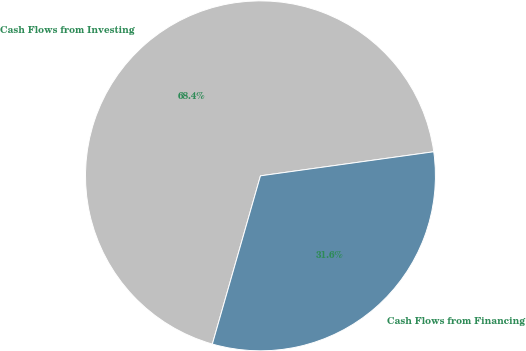Convert chart. <chart><loc_0><loc_0><loc_500><loc_500><pie_chart><fcel>Cash Flows from Investing<fcel>Cash Flows from Financing<nl><fcel>68.37%<fcel>31.63%<nl></chart> 